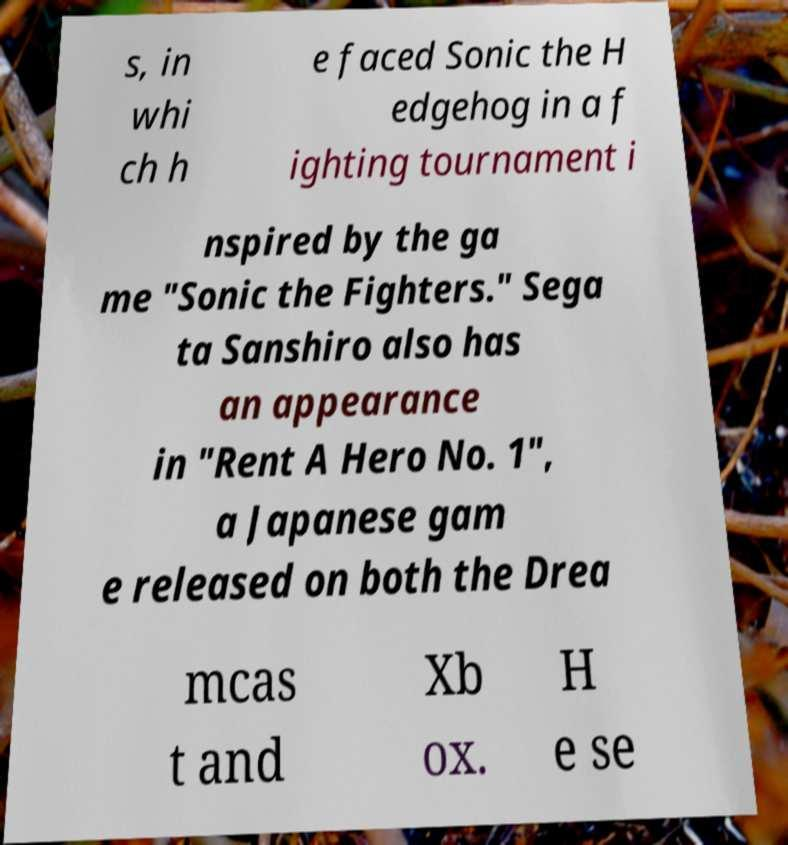Can you read and provide the text displayed in the image?This photo seems to have some interesting text. Can you extract and type it out for me? s, in whi ch h e faced Sonic the H edgehog in a f ighting tournament i nspired by the ga me "Sonic the Fighters." Sega ta Sanshiro also has an appearance in "Rent A Hero No. 1", a Japanese gam e released on both the Drea mcas t and Xb ox. H e se 